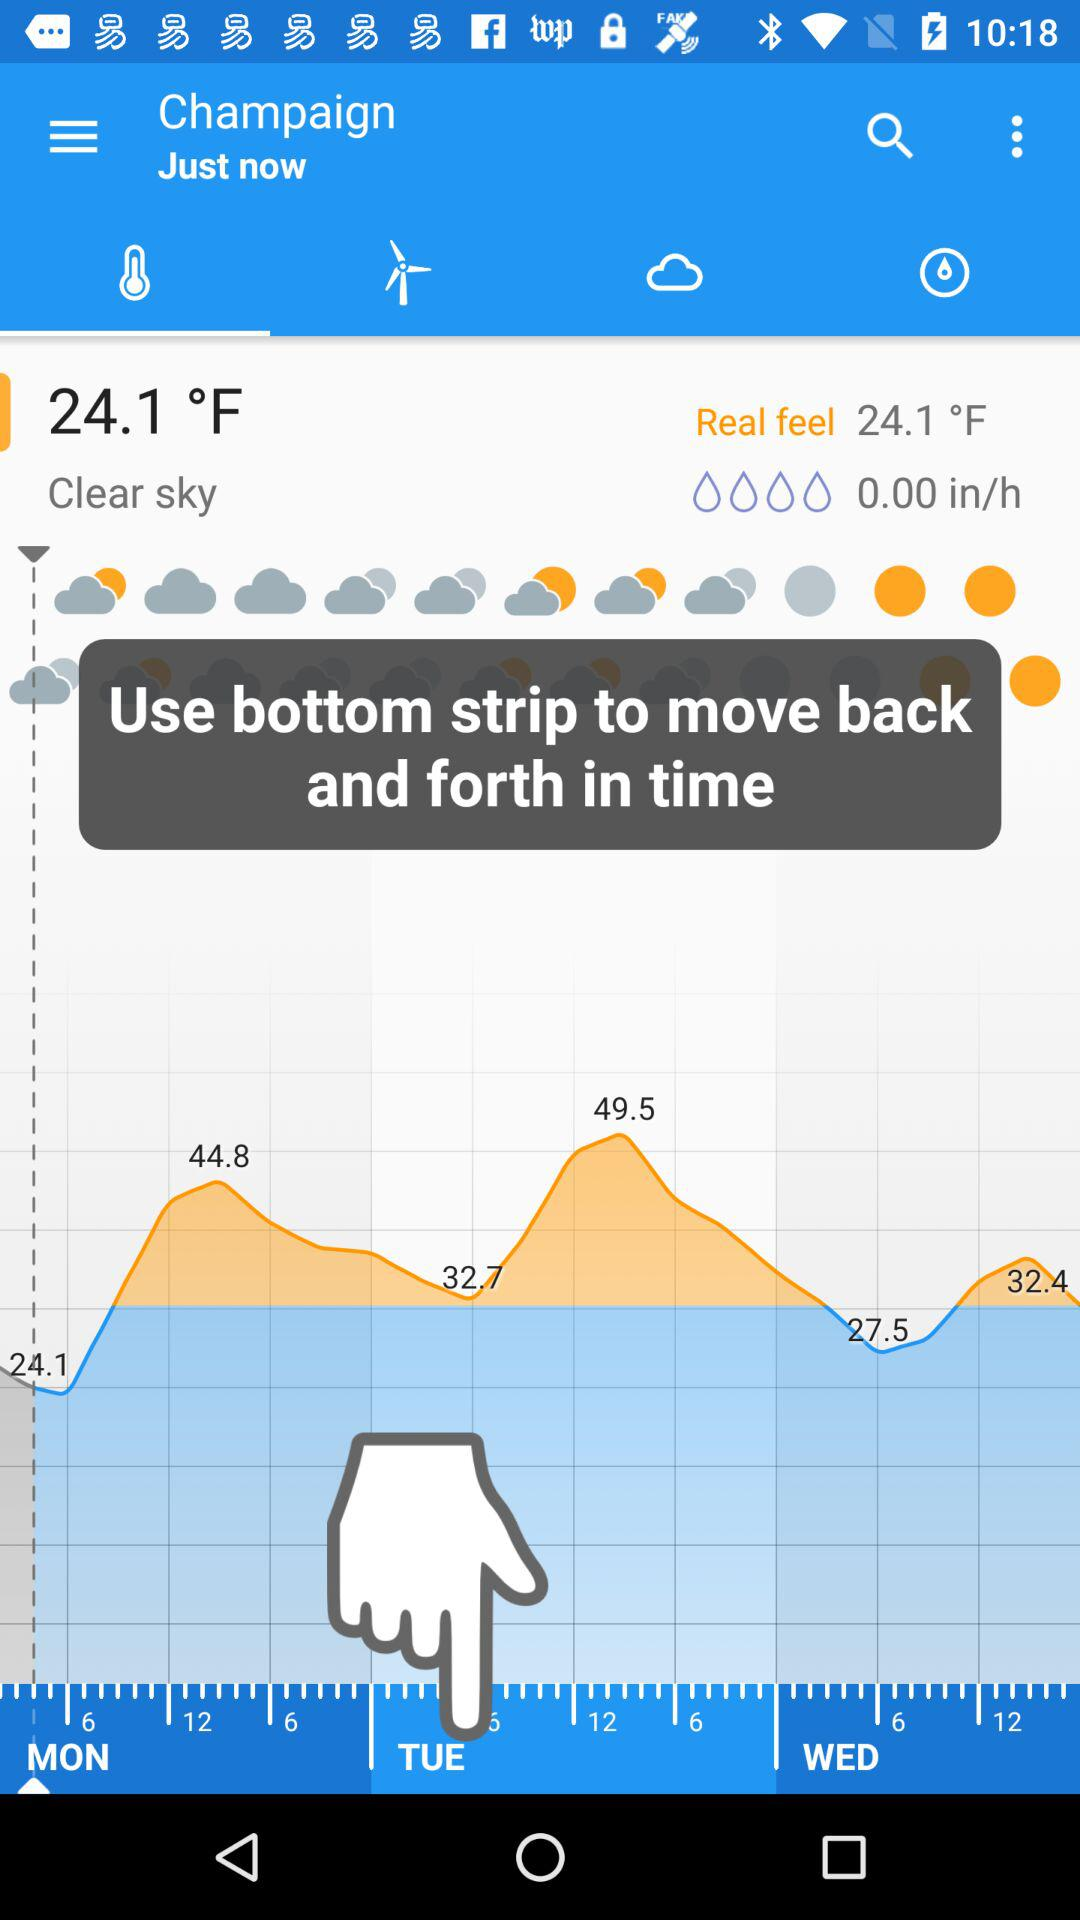How many days are displayed in this weather forecast?
Answer the question using a single word or phrase. 3 